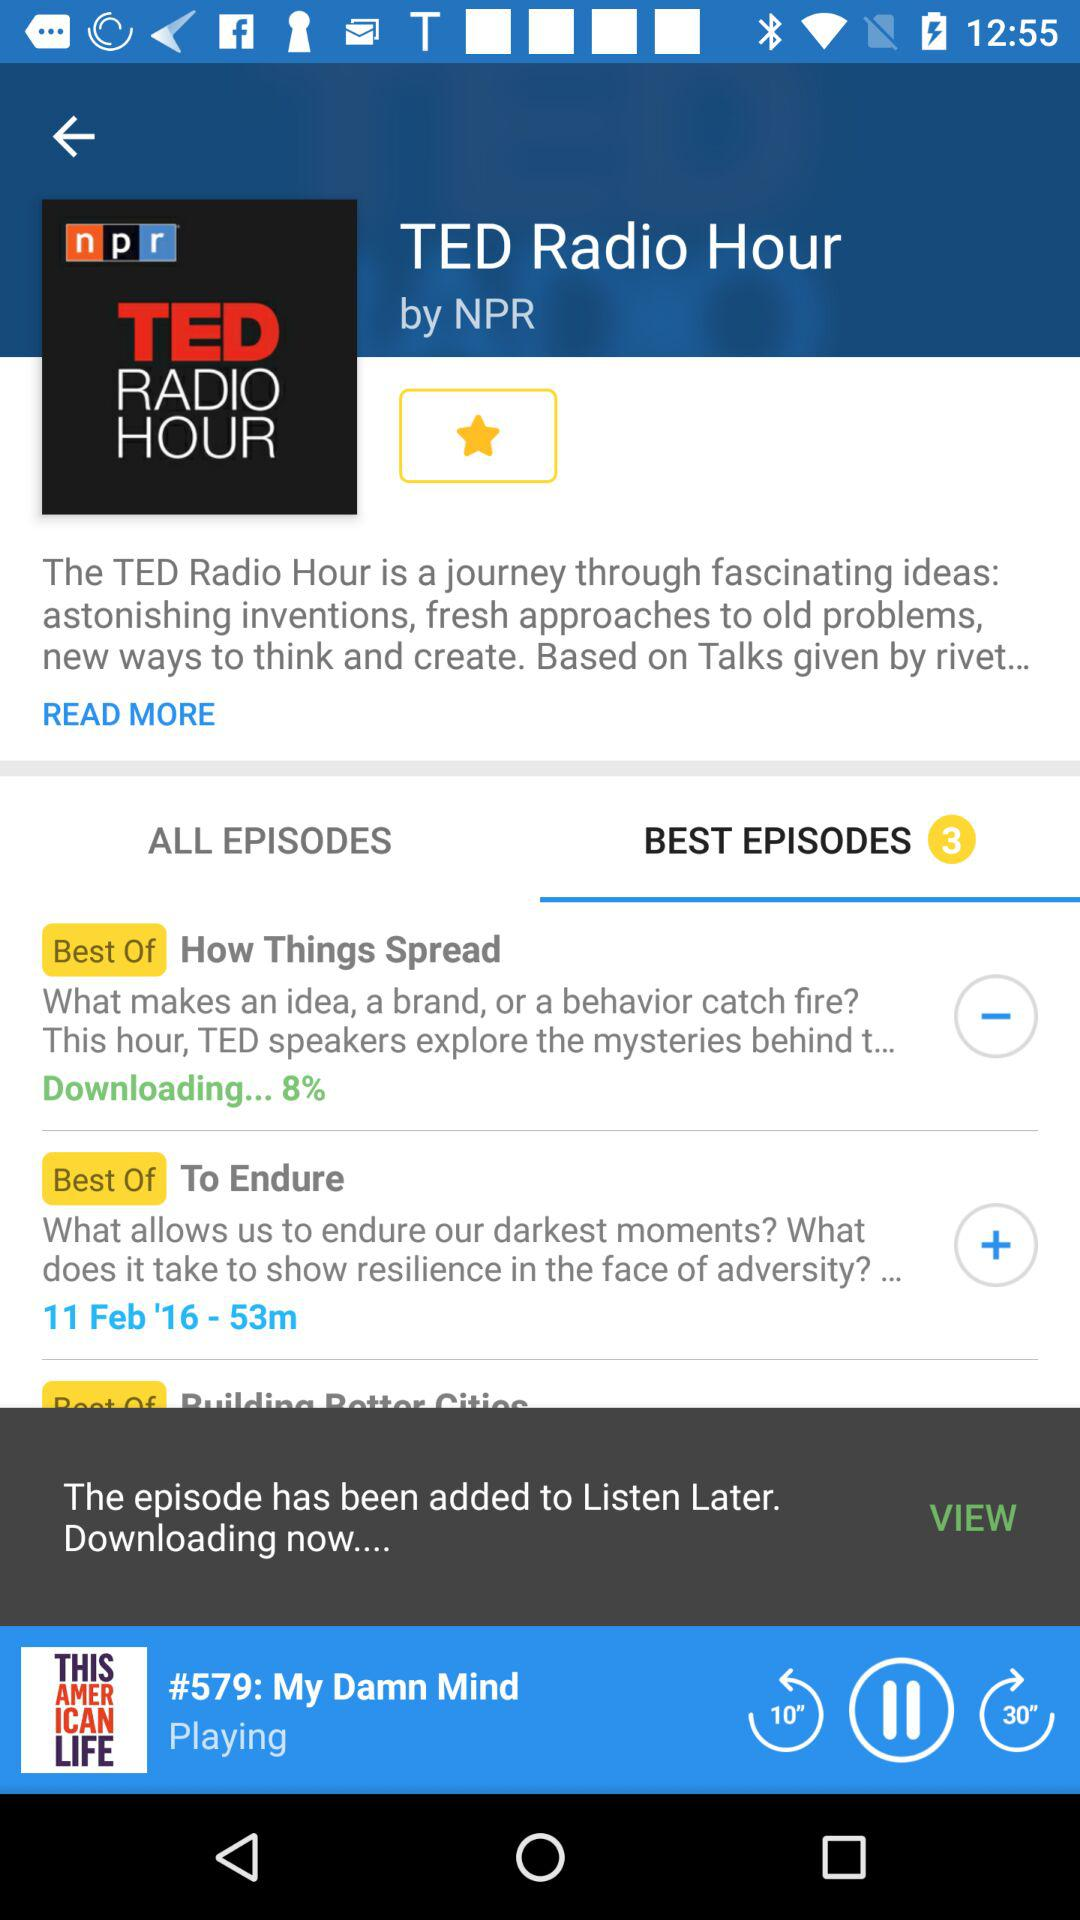Which episode is playing? The episode that is playing is "My Damn Mind". 